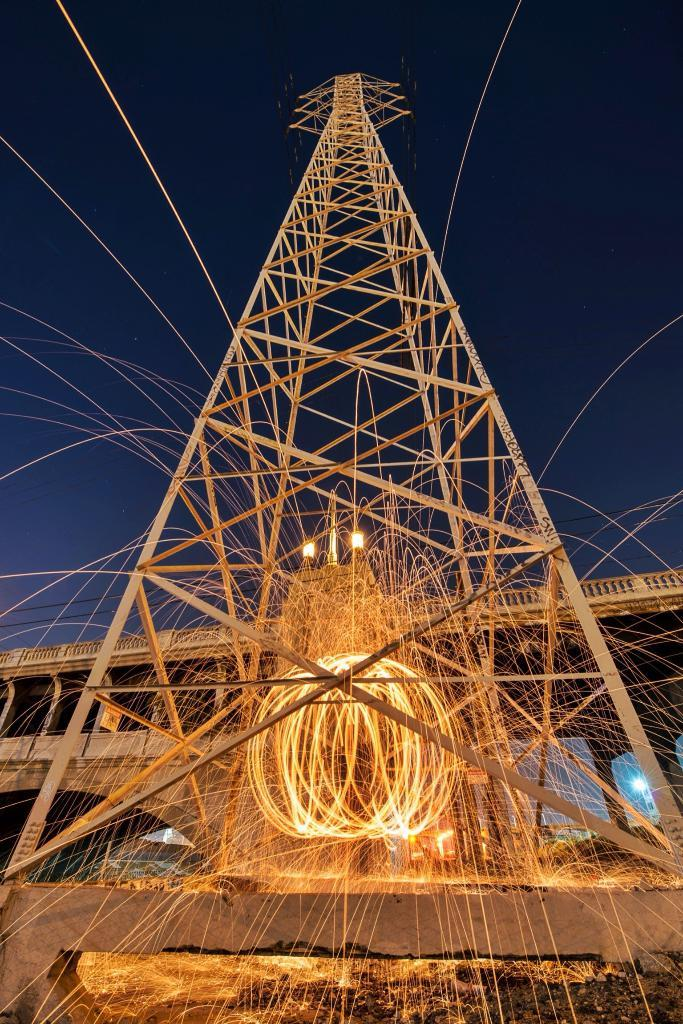What type of structure is in the image? There is a metal rod tower in the image. What can be seen in the middle of the tower? There are fire rings in the middle of the tower. What is located behind the tower? There is a bridge behind the tower. What can be seen in the background of the image? The sky is visible in the background of the image. What type of pest can be seen crawling on the wall in the image? There is no wall or pest present in the image. What is the hook used for in the image? There is no hook present in the image. 